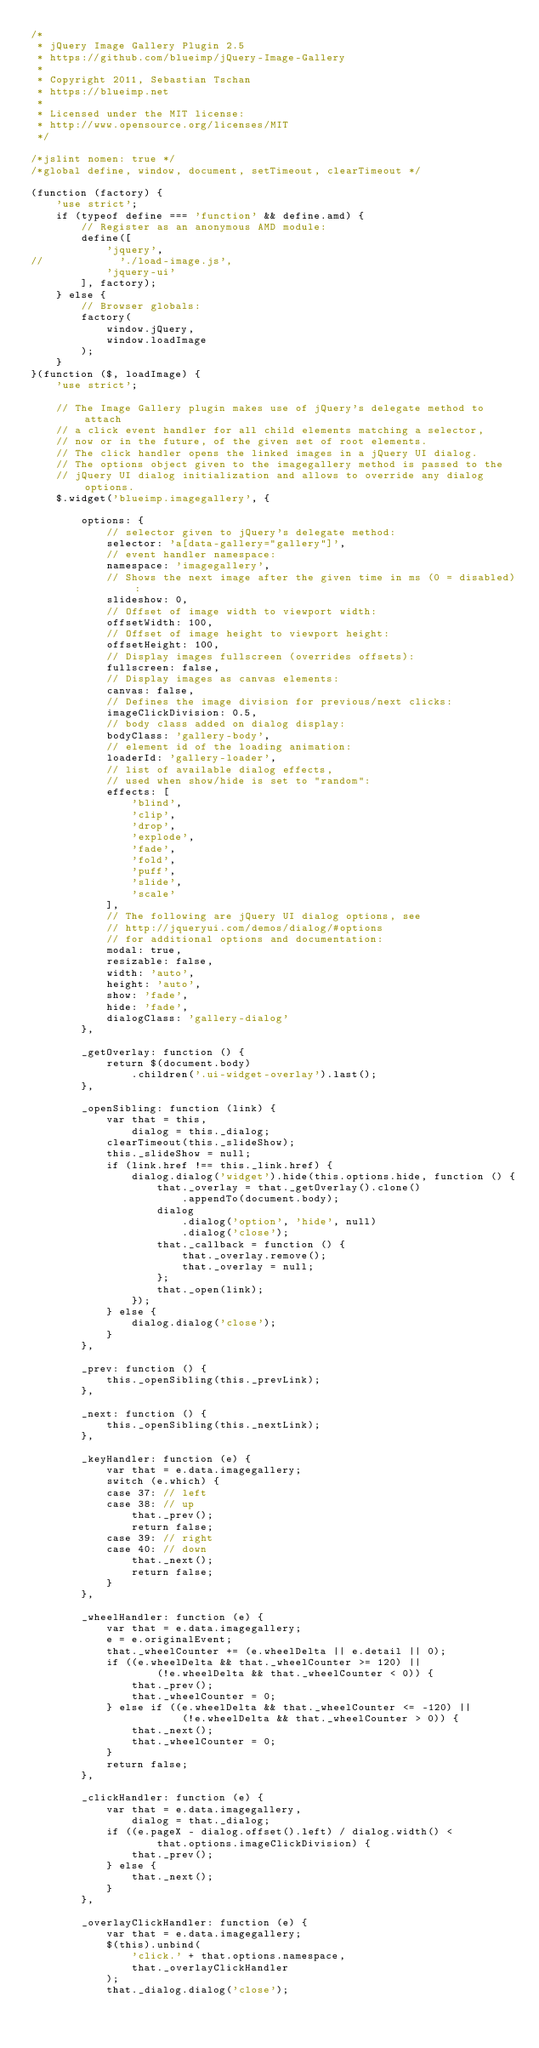<code> <loc_0><loc_0><loc_500><loc_500><_JavaScript_>/*
 * jQuery Image Gallery Plugin 2.5
 * https://github.com/blueimp/jQuery-Image-Gallery
 *
 * Copyright 2011, Sebastian Tschan
 * https://blueimp.net
 *
 * Licensed under the MIT license:
 * http://www.opensource.org/licenses/MIT
 */

/*jslint nomen: true */
/*global define, window, document, setTimeout, clearTimeout */

(function (factory) {
    'use strict';
    if (typeof define === 'function' && define.amd) {
        // Register as an anonymous AMD module:
        define([
            'jquery',
//            './load-image.js',
            'jquery-ui'
        ], factory);
    } else {
        // Browser globals:
        factory(
            window.jQuery,
            window.loadImage
        );
    }
}(function ($, loadImage) {
    'use strict';

    // The Image Gallery plugin makes use of jQuery's delegate method to attach
    // a click event handler for all child elements matching a selector,
    // now or in the future, of the given set of root elements.
    // The click handler opens the linked images in a jQuery UI dialog.
    // The options object given to the imagegallery method is passed to the
    // jQuery UI dialog initialization and allows to override any dialog options.
    $.widget('blueimp.imagegallery', {

        options: {
            // selector given to jQuery's delegate method:
            selector: 'a[data-gallery="gallery"]',
            // event handler namespace:
            namespace: 'imagegallery',
            // Shows the next image after the given time in ms (0 = disabled):
            slideshow: 0,
            // Offset of image width to viewport width:
            offsetWidth: 100,
            // Offset of image height to viewport height:
            offsetHeight: 100,
            // Display images fullscreen (overrides offsets):
            fullscreen: false,
            // Display images as canvas elements:
            canvas: false,
            // Defines the image division for previous/next clicks:
            imageClickDivision: 0.5,
            // body class added on dialog display:
            bodyClass: 'gallery-body',
            // element id of the loading animation:
            loaderId: 'gallery-loader',
            // list of available dialog effects,
            // used when show/hide is set to "random":
            effects: [
                'blind',
                'clip',
                'drop',
                'explode',
                'fade',
                'fold',
                'puff',
                'slide',
                'scale'
            ],
            // The following are jQuery UI dialog options, see
            // http://jqueryui.com/demos/dialog/#options
            // for additional options and documentation:
            modal: true,
            resizable: false,
            width: 'auto',
            height: 'auto',
            show: 'fade',
            hide: 'fade',
            dialogClass: 'gallery-dialog'
        },

        _getOverlay: function () {
            return $(document.body)
                .children('.ui-widget-overlay').last();
        },

        _openSibling: function (link) {
            var that = this,
                dialog = this._dialog;
            clearTimeout(this._slideShow);
            this._slideShow = null;
            if (link.href !== this._link.href) {
                dialog.dialog('widget').hide(this.options.hide, function () {
                    that._overlay = that._getOverlay().clone()
                        .appendTo(document.body);
                    dialog
                        .dialog('option', 'hide', null)
                        .dialog('close');
                    that._callback = function () {
                        that._overlay.remove();
                        that._overlay = null;
                    };
                    that._open(link);
                });
            } else {
                dialog.dialog('close');
            }
        },

        _prev: function () {
            this._openSibling(this._prevLink);
        },

        _next: function () {
            this._openSibling(this._nextLink);
        },

        _keyHandler: function (e) {
            var that = e.data.imagegallery;
            switch (e.which) {
            case 37: // left
            case 38: // up
                that._prev();
                return false;
            case 39: // right
            case 40: // down
                that._next();
                return false;
            }
        },

        _wheelHandler: function (e) {
            var that = e.data.imagegallery;
            e = e.originalEvent;
            that._wheelCounter += (e.wheelDelta || e.detail || 0);
            if ((e.wheelDelta && that._wheelCounter >= 120) ||
                    (!e.wheelDelta && that._wheelCounter < 0)) {
                that._prev();
                that._wheelCounter = 0;
            } else if ((e.wheelDelta && that._wheelCounter <= -120) ||
                        (!e.wheelDelta && that._wheelCounter > 0)) {
                that._next();
                that._wheelCounter = 0;
            }
            return false;
        },

        _clickHandler: function (e) {
            var that = e.data.imagegallery,
                dialog = that._dialog;
            if ((e.pageX - dialog.offset().left) / dialog.width() <
                    that.options.imageClickDivision) {
                that._prev();
            } else {
                that._next();
            }
        },

        _overlayClickHandler: function (e) {
            var that = e.data.imagegallery;
            $(this).unbind(
                'click.' + that.options.namespace,
                that._overlayClickHandler
            );
            that._dialog.dialog('close');</code> 